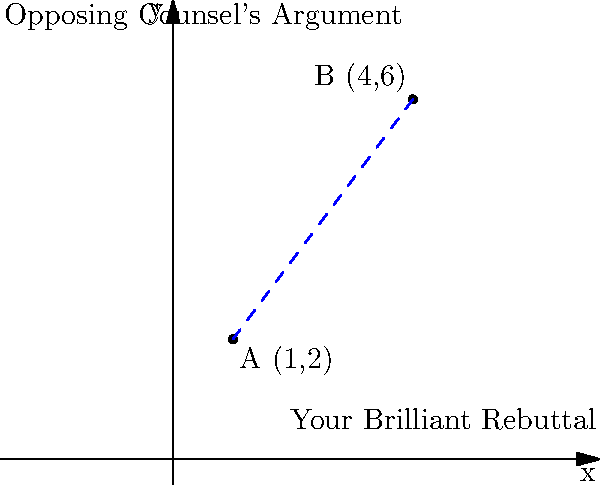In the courtroom of analytical geometry, you find yourself facing off against opposing counsel. Your argument is brilliantly positioned at point A (1, 2), while your opponent's less compelling case stands at point B (4, 6). Calculate the distance between these two points to determine just how far apart your legal perspectives truly are. (Hint: You might want to dust off that Pythagorean theorem from your law school days!) Let's approach this case step by step:

1) We can use the distance formula, which is derived from the Pythagorean theorem:
   $$ d = \sqrt{(x_2 - x_1)^2 + (y_2 - y_1)^2} $$

2) We have:
   Point A: (1, 2)
   Point B: (4, 6)

3) Let's plug these into our formula:
   $$ d = \sqrt{(4 - 1)^2 + (6 - 2)^2} $$

4) Simplify inside the parentheses:
   $$ d = \sqrt{3^2 + 4^2} $$

5) Calculate the squares:
   $$ d = \sqrt{9 + 16} $$

6) Add inside the square root:
   $$ d = \sqrt{25} $$

7) Simplify:
   $$ d = 5 $$

Therefore, the distance between your argument and opposing counsel's is 5 units. In the courtroom, as in geometry, it's all about closing the distance!
Answer: 5 units 